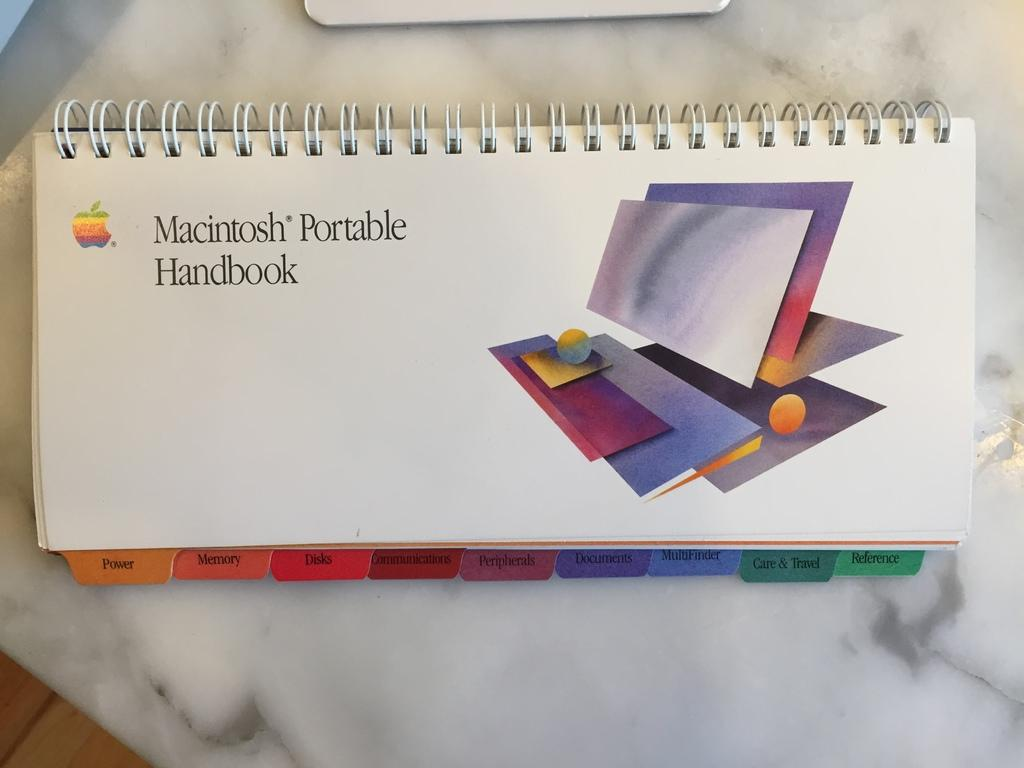<image>
Offer a succinct explanation of the picture presented. A handbook for a Macintosh and that has many different tabs in it. 